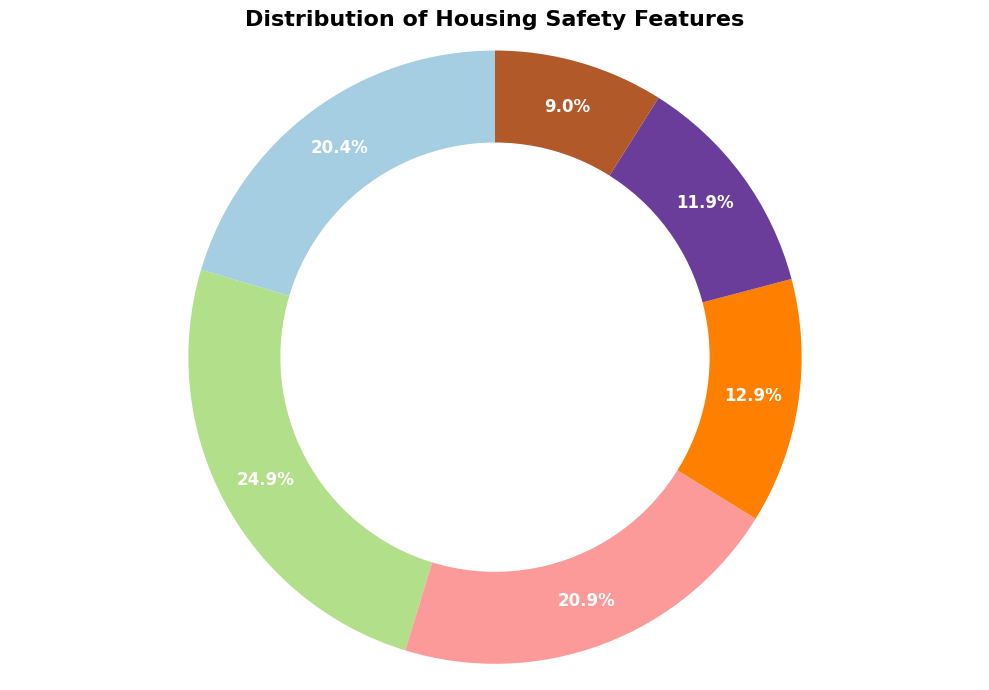Which neighborhood has the highest percentage of Fire Alarms? The wedge representing Fire Alarms will show which neighborhood has the largest section if the chart is split into neighborhoods. Compute the percentage contribution and see which neighborhood has the highest. The ring-chart shows which safety feature has the dominant percentage. Sunnydale has 25 Fire Alarms.
Answer: Sunnydale Which safety feature has the smallest percentage distribution? Look for the smallest wedge in the ring chart, which represents the distribution of the safety feature. Locate the wedge that occupies the least space.
Answer: Lighting What is the total percentage of neighborhoods with more than 20 Security Systems? First, identify the neighborhoods meeting this criterion (Sunnydale, Greenwood, Pinecrest, Silverlake), then compute their percentages. Sum these values to get the total percentage.
Answer: 40.0% Which takes up more percentage in total: Child Proof Locks or Guard Rails? Compare the sizes of the wedges representing Child Proof Locks and Guard Rails. Sum the values for both and compare which is larger on the chart. Sum for Child Proof Locks = 190, Guard Rails = 125, Child Proof Locks have a larger wedge.
Answer: Child Proof Locks How does the percentage of neighborhoods with Emergency Exits compare to those with Lighting? Locate and compare the sizes of the wedges for Emergency Exits and Lighting. View which safety feature occupies a larger segment in the ring chart. Emergency Exits appear larger than Lighting.
Answer: Emergency Exits Which feature is more evenly distributed across neighborhoods: Fire Alarms or Child Proof Locks? Determine variance by visually inspecting the wedges for evenness. Multiple neighborhoods contributing similar-sized wedges to a feature indicate even distribution. Child Proof Locks show more evenly sized wedges.
Answer: Child Proof Locks 